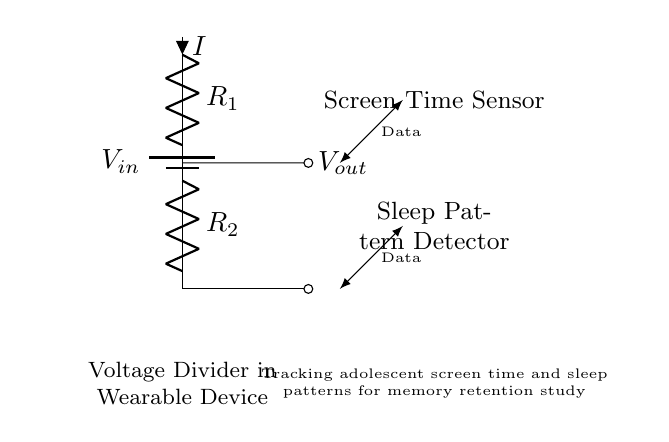What is the total resistance in this circuit? The total resistance can be calculated using the formula for resistors in series, which is R_total = R1 + R2. In the circuit diagram, R1 and R2 are the resistances connected end-to-end, so we add their values together.
Answer: Total resistance is R1 + R2 What is the output voltage of the voltage divider? The output voltage is given by the formula V_out = V_in * (R2 / (R1 + R2)). This shows how the input voltage is divided between the two resistors according to their values.
Answer: V_out is V_in * (R2 / (R1 + R2)) What type of sensors are used in this circuit? The circuit diagram indicates two types of sensors, one for screen time and one for sleep patterns, as labeled next to the respective circuits.
Answer: Screen Time Sensor and Sleep Pattern Detector How does this voltage divider relate to tracking sleep patterns? The voltage divider function is used to reduce the input voltage from sensors, which allows the output to be safely processed by the microcontroller. This is crucial for accurately capturing sleep data without overwhelming the system.
Answer: It reduces voltage for safe processing What is the purpose of the short circuit at the output? The short circuit at the output provides a means to connect the voltage signal to further processing for data collection purpose, allowing the system to analyze the reduced voltage corresponding to the findings from the sensors.
Answer: Connects output for data collection 